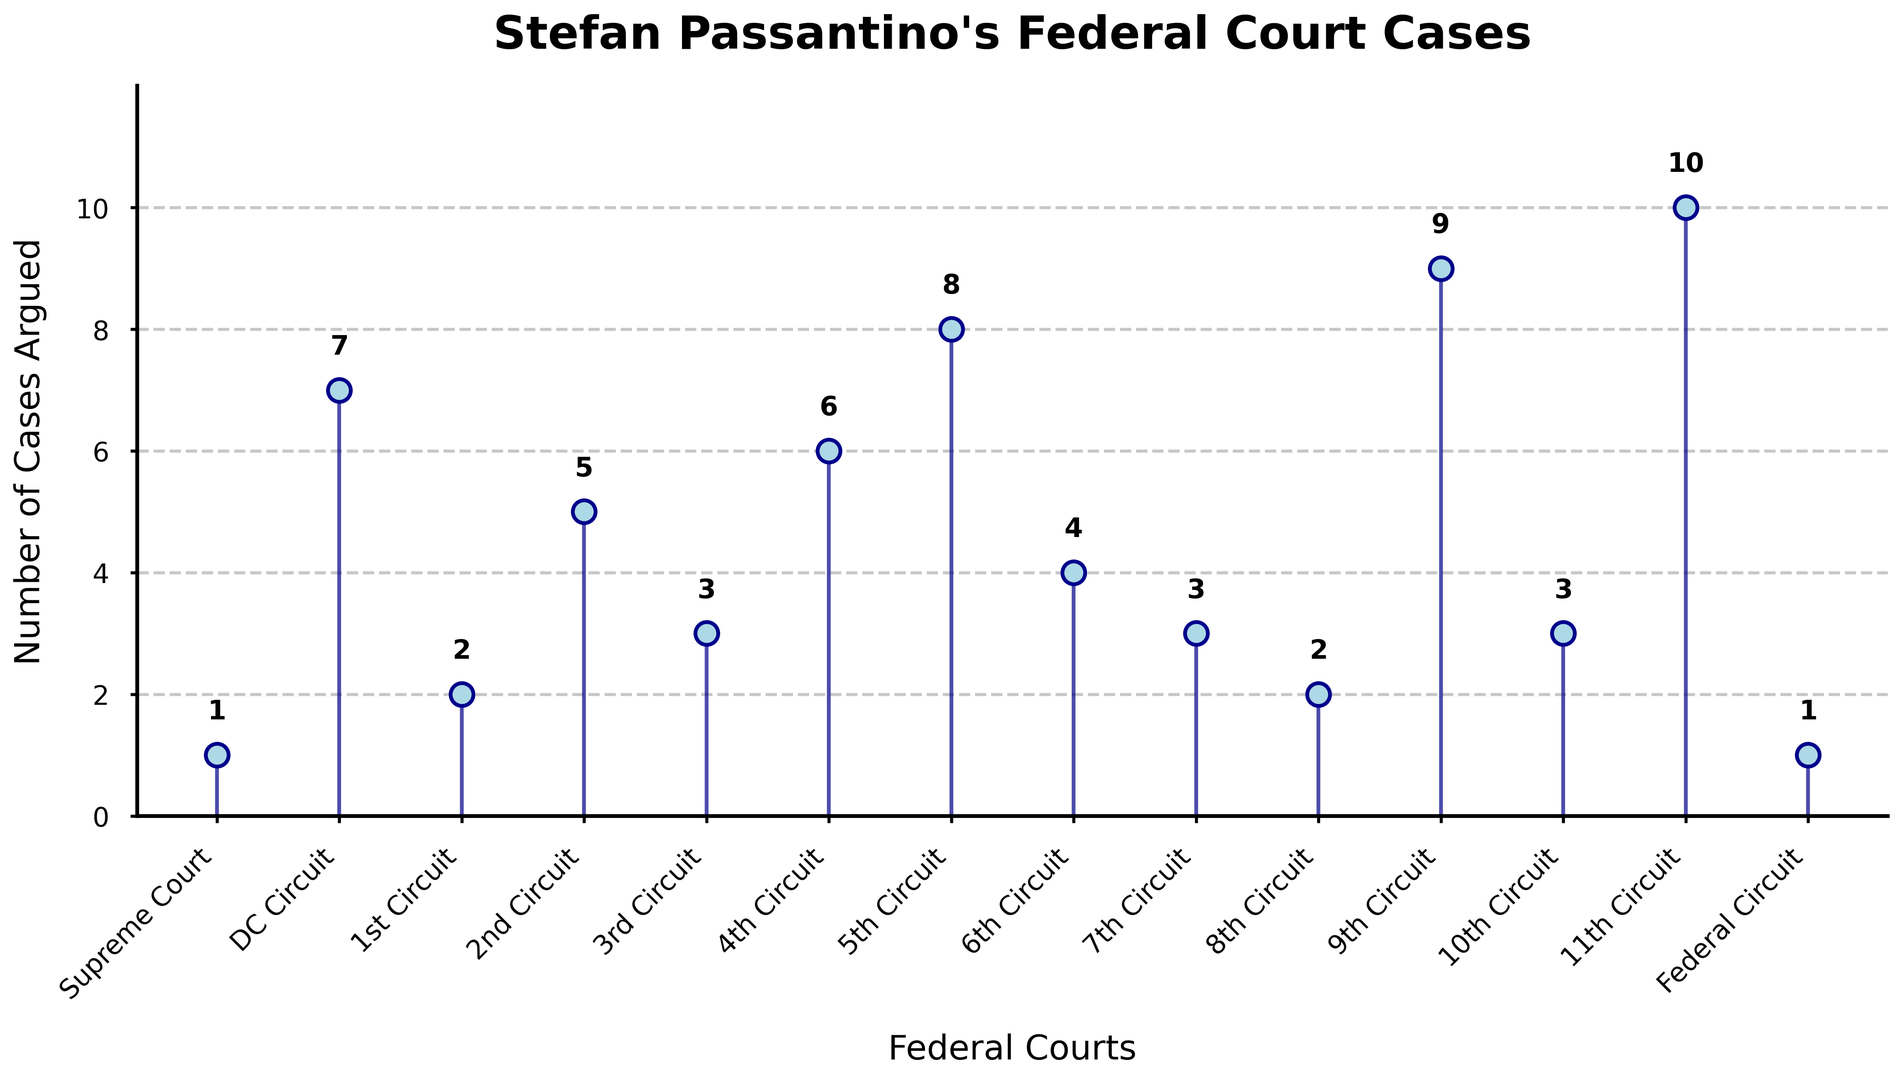Which court has the highest number of cases argued by Stefan Passantino? The number of cases argued is represented by the vertical height of the graphical marks. The court with the highest vertical mark indicates the highest number of cases, which is the 11th Circuit.
Answer: 11th Circuit Which court has argued only one case? Looking at the vertical heights of the graphical marks, only the marks for "Supreme Court" and "Federal Circuit" reach a height of 1, indicating they each have only one case argued.
Answer: Supreme Court, Federal Circuit How many more cases has Stefan argued in the 9th Circuit compared to the 5th Circuit? From the vertical heights and labels, the 9th Circuit has 9 cases while the 5th Circuit has 8. The difference is 9 - 8 = 1.
Answer: 1 What's the total number of cases argued in the 1st Circuit, 3rd Circuit, and 8th Circuit combined? Adding the number of cases in these circuits, we get 2 (1st Circuit) + 3 (3rd Circuit) + 2 (8th Circuit) = 7.
Answer: 7 Which circuits have argued the same number of cases? The circuits with the same vertical marks are: 1st Circuit and 8th Circuit (both with 2 cases), 3rd Circuit, 7th Circuit, and 10th Circuit (all with 3 cases).
Answer: 1st & 8th Circuit; 3rd, 7th & 10th Circuit On average, how many cases has Stefan argued across all circuits? The total number of cases argued is the sum of all values, 66, and there are 14 courts. The average is 66 / 14 ≈ 4.71.
Answer: 4.71 How many cases were argued in circuits with more than 5 cases? Circuits with more than 5 cases: DC Circuit (7), 2nd Circuit (5), 4th Circuit (6), 5th Circuit (8), 9th Circuit (9), 11th Circuit (10). Adding these we get 7 + 6 + 8 + 9 + 10 = 40.
Answer: 40 What is the median number of cases argued per court? To find the median, sort the cases: 1, 1, 2, 2, 3, 3, 3, 4, 5, 6, 7, 8, 9, 10. The middle values (7th and 8th in the list) are both 3 and 4. The median is the average of these two values, (3 + 4) / 2 = 3.5.
Answer: 3.5 In which court has Stefan argued four times? The height of the graphical mark for the 6th Circuit is 4, indicating 4 cases argued.
Answer: 6th Circuit 